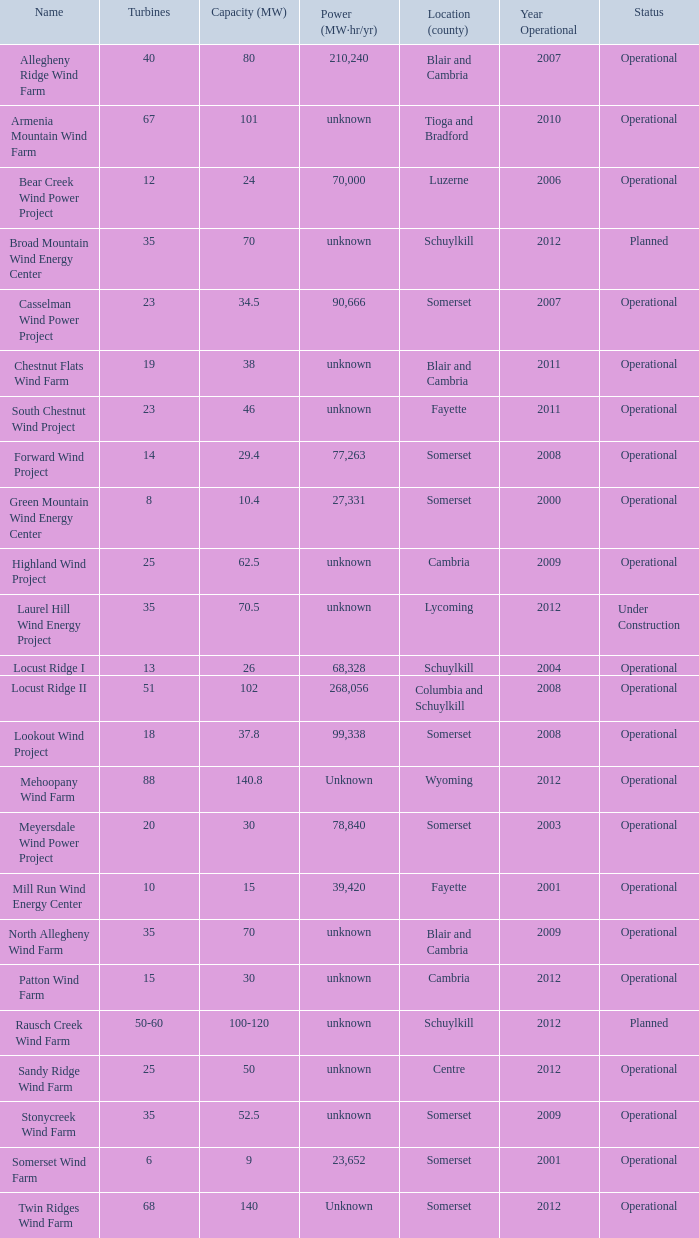What all capacities have turbines between 50-60? 100-120. 